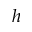<formula> <loc_0><loc_0><loc_500><loc_500>h</formula> 